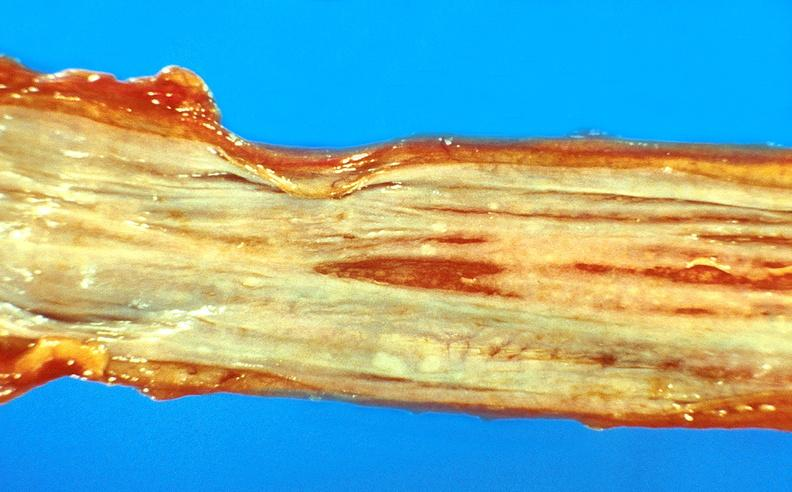does sickle cell disease show esophageal varices?
Answer the question using a single word or phrase. No 